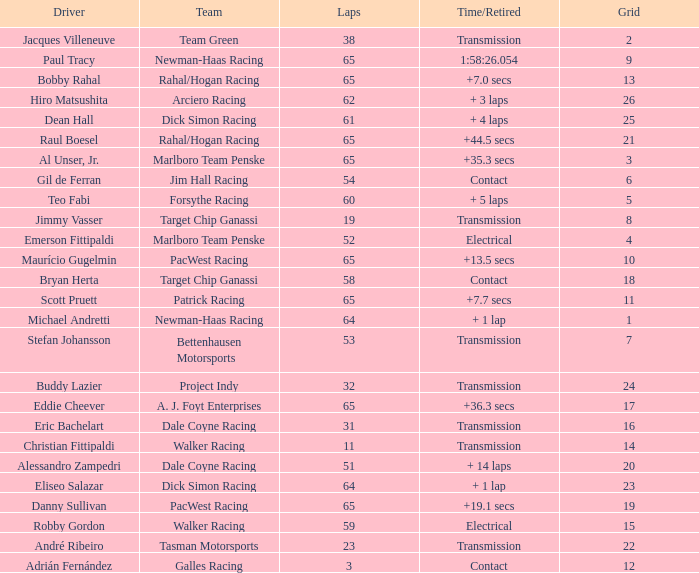What was the highest grid for a time/retired of +19.1 secs? 19.0. 